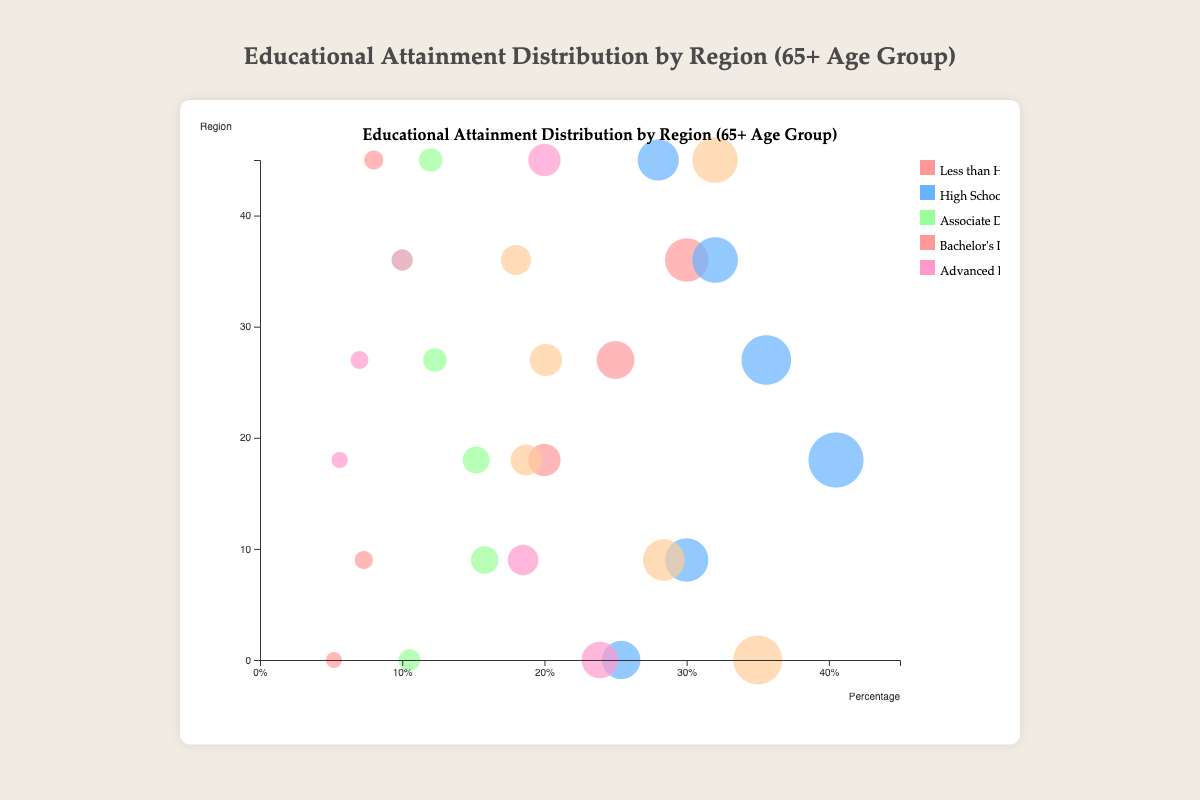What's the title of the chart? The title is usually located at the top of the chart and gives a brief description of its content. In this case, it reads "Educational Attainment Distribution by Region (65+ Age Group)".
Answer: Educational Attainment Distribution by Region (65+ Age Group) Which region has the highest percentage of people with less than a high school education? Look at the circles representing the "Less than High School" category and compare their positions based on the x-axis. The circle for Africa has the highest value.
Answer: Africa What is the approximate percentage of people with advanced degrees in Europe? Identify the circle representing "Advanced Degree" in Europe by looking at the color and legend. The tooltip or position on the x-axis provides the percentage, which is around 18.5%.
Answer: 18.5% Which region has the lowest percentage of individuals with a bachelor's degree? Compare the positions of circles that represent the "Bachelor Degree" category across different regions. Asia has the lowest percentage, as its circle is the furthest left on the x-axis for this category.
Answer: Asia How does the percentage of people with high school diplomas in North America compare to those in Asia? Locate and compare the circles representing "High School Diploma" for North America and Asia based on their positions on the x-axis. North America has 25.4%, while Asia has 40.5%.
Answer: North America has a lower percentage than Asia In which region do individuals with associate degrees constitute at least 15%? We need to find the regions where circles for "Associate Degree" are at 15% or more on the x-axis. Europe and Asia meet this criterion.
Answer: Europe and Asia What is the approximate percentage difference between people with advanced degrees in North America and South America? Find the relevant circles for "Advanced Degree" in North America (23.9%) and South America (7%), then calculate the difference (23.9% - 7% = 16.9%).
Answer: 16.9% Which regions have more than 30% of individuals with high school diplomas? Identify circles for "High School Diploma" across all regions and check which ones are above 30% on the x-axis. Europe (30%), Asia (40.5%), South America (35.6%), and Africa (32%) have more than 30%.
Answer: Europe, Asia, South America, and Africa Which category of educational attainment has the largest bubble size in the chart? The largest bubbles represent the highest percentages. The “High School Diploma” category in Asia has the largest bubble size.
Answer: High School Diploma in Asia Compare the proportions of people with associate degrees in Europe and Africa. Which is higher, and by how much? Look at the circles for "Associate Degree" in both regions and check their percentages represented by the x-axis. Europe is 15.8%, and Africa is 10%, making Europe higher by 5.8%.
Answer: Europe by 5.8% 